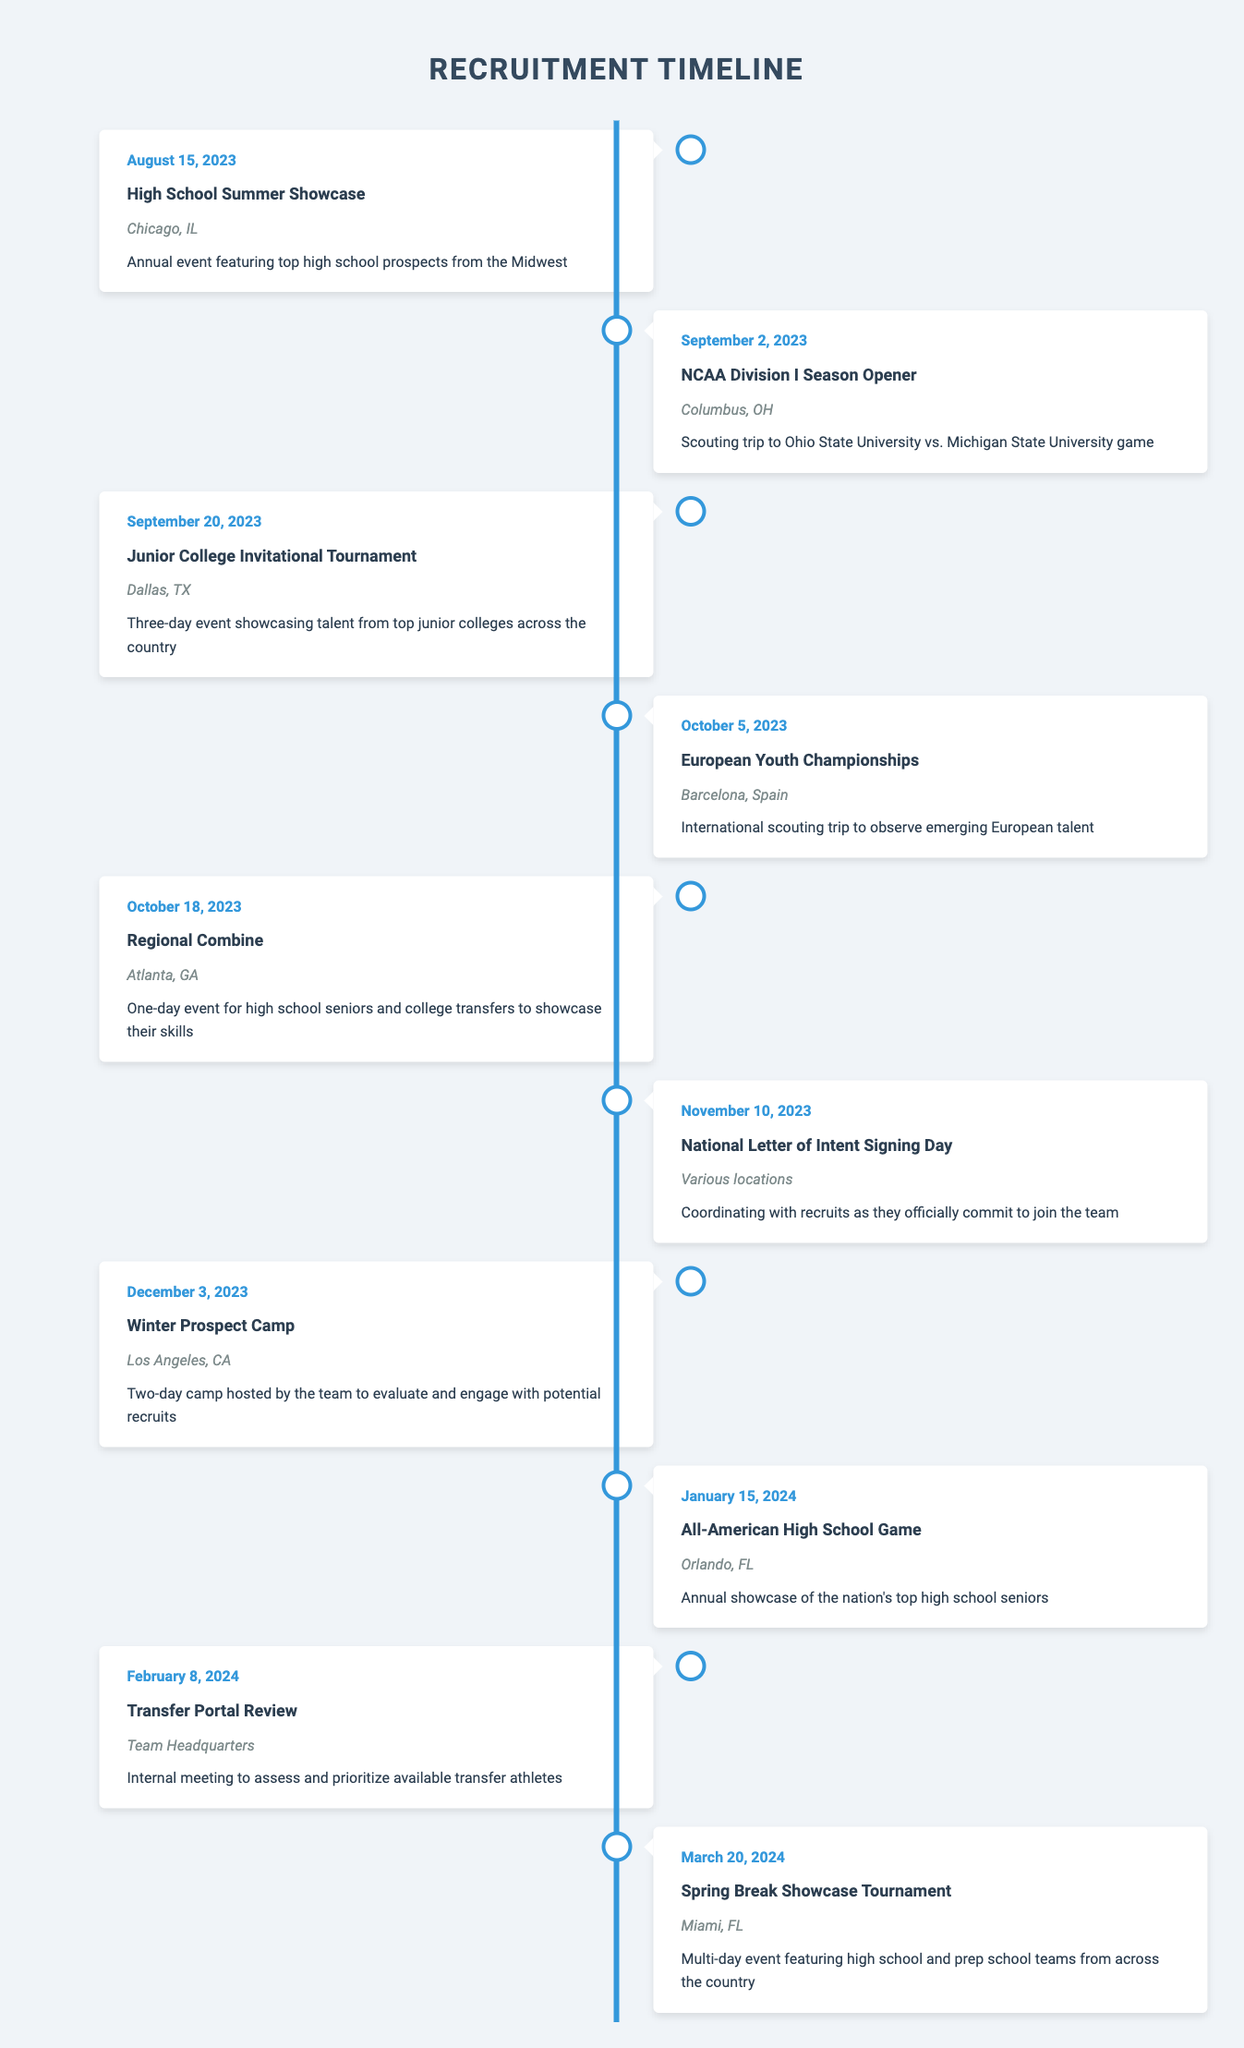What event is taking place on September 2, 2023? The table lists "NCAA Division I Season Opener" as the event for September 2, 2023.
Answer: NCAA Division I Season Opener How many events are scheduled in October 2023? There are two events scheduled in October 2023: "European Youth Championships" on October 5 and "Regional Combine" on October 18.
Answer: 2 Is the "National Letter of Intent Signing Day" an event that takes place before November 10, 2023? According to the table, the "National Letter of Intent Signing Day" is on November 10, 2023, confirming that it does not take place before this date.
Answer: No What is the location for the Winter Prospect Camp? The table specifies that the Winter Prospect Camp will be held in "Los Angeles, CA."
Answer: Los Angeles, CA How many days does the Junior College Invitational Tournament last? The Junior College Invitational Tournament is described as a three-day event, indicating that it spans three days.
Answer: 3 Which event is hosted internationally, and what is its location? The "European Youth Championships" is the event hosted internationally, and it takes place in "Barcelona, Spain."
Answer: European Youth Championships in Barcelona, Spain How does the number of events in December compare to those in January? There is one event in December (Winter Prospect Camp) and one event in January (All-American High School Game), making it an equal comparison with each month having one event.
Answer: Same (1 event each) Which event is associated with high school seniors and on what date does it occur? The "All-American High School Game" is specifically associated with high school seniors and is scheduled for January 15, 2024.
Answer: January 15, 2024 What is the last recruitment event listed in this timeline? "Spring Break Showcase Tournament" on March 20, 2024, is the last recruitment event as per the timeline presented in the table.
Answer: Spring Break Showcase Tournament 